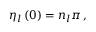<formula> <loc_0><loc_0><loc_500><loc_500>\eta _ { l } \left ( 0 \right ) = n _ { l } \pi \, ,</formula> 